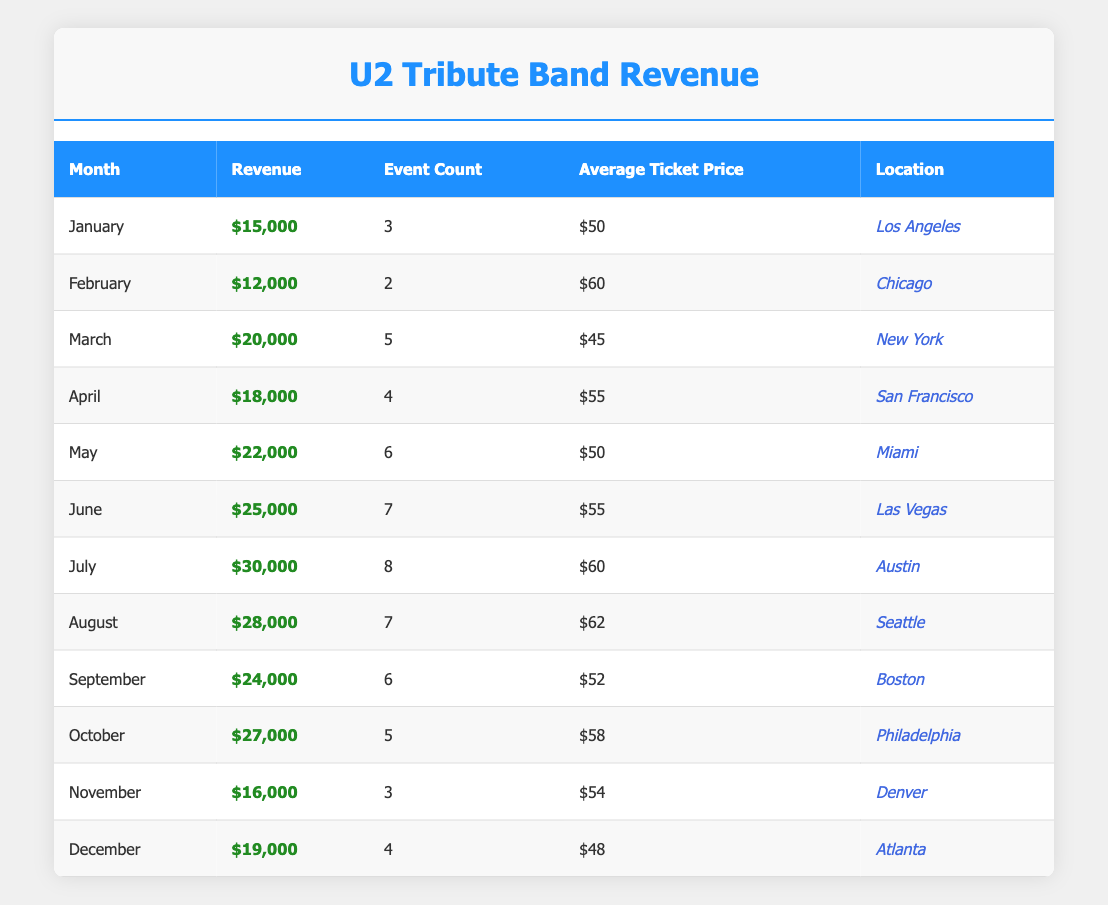What is the total revenue generated from U2 tribute band events in July? The revenue for July is listed in the table as $30,000.
Answer: $30,000 In which month was the average ticket price the highest? Looking at the table, August has the highest average ticket price at $62.
Answer: August How much revenue was generated from events in New York? In the table, the revenue for March, which is when the events occurred in New York, is recorded as $20,000.
Answer: $20,000 What is the average revenue generated per event in June? To find this, divide the total revenue in June ($25,000) by the number of events (7), giving an average of $3,571.43 per event.
Answer: $3,571.43 Was the total revenue in the second half of the year higher than the first half? Adding the revenues for the first half (January to June) gives $15000 + $12000 + $20000 + $18000 + $22000 + $25000 = $112000. For the second half (July to December), the total is $30000 + $28000 + $24000 + $27000 + $16000 + $19000 = $144000. Since $144000 is greater than $112000, the statement is true.
Answer: Yes What was the average ticket price for all events in May and June combined? The average ticket price in May is $50, and in June, it is $55. To find the average, calculate (50 + 55) / 2 = $52.50.
Answer: $52.50 How many events were held in San Francisco, and what was the total revenue from those events? The table shows there were 4 events in April in San Francisco with a total revenue of $18,000.
Answer: 4 events, $18,000 Was the revenue generated from events in Denver higher than in Los Angeles? The revenue for Los Angeles in January is $15,000, and for Denver in November, it is $16,000. Since $16,000 is greater than $15,000, the statement is true.
Answer: Yes What is the difference in revenue between the month with the highest and the month with the lowest revenue? The highest revenue is from July at $30,000 and the lowest is from February at $12,000. The difference is $30,000 - $12,000 = $18,000.
Answer: $18,000 